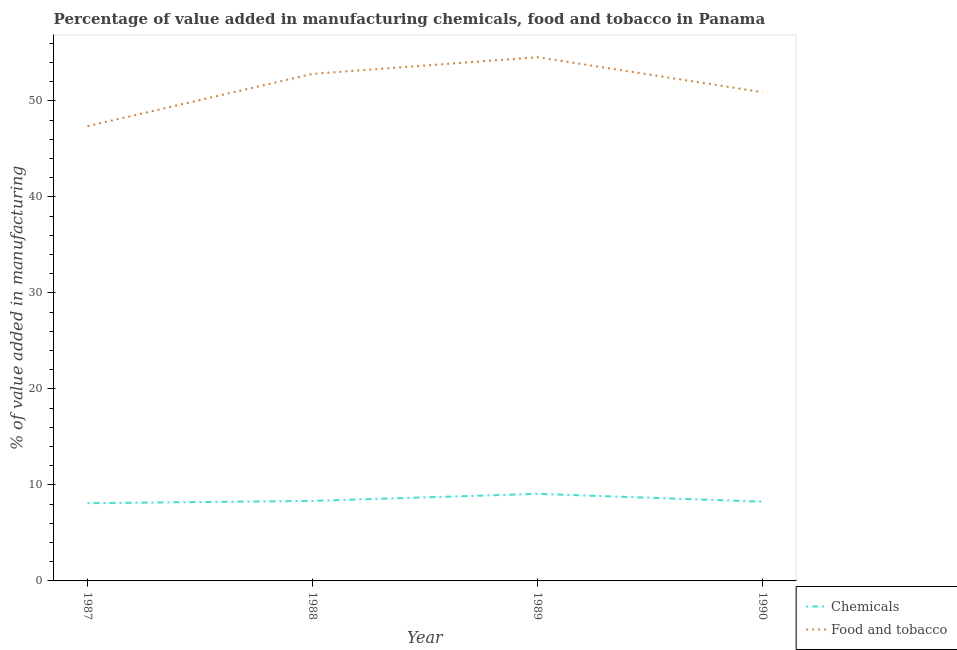Does the line corresponding to value added by manufacturing food and tobacco intersect with the line corresponding to value added by  manufacturing chemicals?
Ensure brevity in your answer.  No. What is the value added by manufacturing food and tobacco in 1989?
Provide a succinct answer. 54.56. Across all years, what is the maximum value added by  manufacturing chemicals?
Your answer should be compact. 9.07. Across all years, what is the minimum value added by  manufacturing chemicals?
Offer a very short reply. 8.1. What is the total value added by  manufacturing chemicals in the graph?
Your response must be concise. 33.76. What is the difference between the value added by  manufacturing chemicals in 1989 and that in 1990?
Ensure brevity in your answer.  0.81. What is the difference between the value added by  manufacturing chemicals in 1989 and the value added by manufacturing food and tobacco in 1990?
Keep it short and to the point. -41.85. What is the average value added by  manufacturing chemicals per year?
Your response must be concise. 8.44. In the year 1988, what is the difference between the value added by manufacturing food and tobacco and value added by  manufacturing chemicals?
Make the answer very short. 44.49. In how many years, is the value added by manufacturing food and tobacco greater than 36 %?
Offer a terse response. 4. What is the ratio of the value added by manufacturing food and tobacco in 1989 to that in 1990?
Offer a very short reply. 1.07. Is the value added by manufacturing food and tobacco in 1987 less than that in 1988?
Give a very brief answer. Yes. What is the difference between the highest and the second highest value added by manufacturing food and tobacco?
Your answer should be compact. 1.74. What is the difference between the highest and the lowest value added by  manufacturing chemicals?
Keep it short and to the point. 0.97. In how many years, is the value added by manufacturing food and tobacco greater than the average value added by manufacturing food and tobacco taken over all years?
Give a very brief answer. 2. Does the value added by manufacturing food and tobacco monotonically increase over the years?
Offer a very short reply. No. Is the value added by manufacturing food and tobacco strictly greater than the value added by  manufacturing chemicals over the years?
Give a very brief answer. Yes. How many lines are there?
Your answer should be very brief. 2. Does the graph contain any zero values?
Give a very brief answer. No. Does the graph contain grids?
Your answer should be very brief. No. How many legend labels are there?
Give a very brief answer. 2. How are the legend labels stacked?
Provide a short and direct response. Vertical. What is the title of the graph?
Offer a terse response. Percentage of value added in manufacturing chemicals, food and tobacco in Panama. What is the label or title of the Y-axis?
Your response must be concise. % of value added in manufacturing. What is the % of value added in manufacturing of Chemicals in 1987?
Your response must be concise. 8.1. What is the % of value added in manufacturing of Food and tobacco in 1987?
Your answer should be compact. 47.37. What is the % of value added in manufacturing of Chemicals in 1988?
Provide a succinct answer. 8.34. What is the % of value added in manufacturing of Food and tobacco in 1988?
Provide a short and direct response. 52.82. What is the % of value added in manufacturing in Chemicals in 1989?
Ensure brevity in your answer.  9.07. What is the % of value added in manufacturing in Food and tobacco in 1989?
Your answer should be very brief. 54.56. What is the % of value added in manufacturing of Chemicals in 1990?
Ensure brevity in your answer.  8.26. What is the % of value added in manufacturing in Food and tobacco in 1990?
Your answer should be very brief. 50.92. Across all years, what is the maximum % of value added in manufacturing in Chemicals?
Make the answer very short. 9.07. Across all years, what is the maximum % of value added in manufacturing of Food and tobacco?
Offer a very short reply. 54.56. Across all years, what is the minimum % of value added in manufacturing in Chemicals?
Offer a terse response. 8.1. Across all years, what is the minimum % of value added in manufacturing of Food and tobacco?
Offer a terse response. 47.37. What is the total % of value added in manufacturing in Chemicals in the graph?
Your response must be concise. 33.76. What is the total % of value added in manufacturing in Food and tobacco in the graph?
Your response must be concise. 205.68. What is the difference between the % of value added in manufacturing of Chemicals in 1987 and that in 1988?
Provide a succinct answer. -0.24. What is the difference between the % of value added in manufacturing in Food and tobacco in 1987 and that in 1988?
Offer a very short reply. -5.45. What is the difference between the % of value added in manufacturing of Chemicals in 1987 and that in 1989?
Your answer should be very brief. -0.97. What is the difference between the % of value added in manufacturing in Food and tobacco in 1987 and that in 1989?
Your response must be concise. -7.19. What is the difference between the % of value added in manufacturing of Chemicals in 1987 and that in 1990?
Provide a short and direct response. -0.16. What is the difference between the % of value added in manufacturing of Food and tobacco in 1987 and that in 1990?
Offer a terse response. -3.54. What is the difference between the % of value added in manufacturing of Chemicals in 1988 and that in 1989?
Your answer should be very brief. -0.73. What is the difference between the % of value added in manufacturing in Food and tobacco in 1988 and that in 1989?
Your response must be concise. -1.74. What is the difference between the % of value added in manufacturing of Chemicals in 1988 and that in 1990?
Your answer should be very brief. 0.08. What is the difference between the % of value added in manufacturing in Food and tobacco in 1988 and that in 1990?
Offer a very short reply. 1.91. What is the difference between the % of value added in manufacturing of Chemicals in 1989 and that in 1990?
Provide a succinct answer. 0.81. What is the difference between the % of value added in manufacturing in Food and tobacco in 1989 and that in 1990?
Ensure brevity in your answer.  3.65. What is the difference between the % of value added in manufacturing of Chemicals in 1987 and the % of value added in manufacturing of Food and tobacco in 1988?
Give a very brief answer. -44.73. What is the difference between the % of value added in manufacturing of Chemicals in 1987 and the % of value added in manufacturing of Food and tobacco in 1989?
Your response must be concise. -46.47. What is the difference between the % of value added in manufacturing of Chemicals in 1987 and the % of value added in manufacturing of Food and tobacco in 1990?
Give a very brief answer. -42.82. What is the difference between the % of value added in manufacturing of Chemicals in 1988 and the % of value added in manufacturing of Food and tobacco in 1989?
Offer a terse response. -46.23. What is the difference between the % of value added in manufacturing of Chemicals in 1988 and the % of value added in manufacturing of Food and tobacco in 1990?
Offer a very short reply. -42.58. What is the difference between the % of value added in manufacturing in Chemicals in 1989 and the % of value added in manufacturing in Food and tobacco in 1990?
Make the answer very short. -41.85. What is the average % of value added in manufacturing of Chemicals per year?
Provide a succinct answer. 8.44. What is the average % of value added in manufacturing of Food and tobacco per year?
Your answer should be very brief. 51.42. In the year 1987, what is the difference between the % of value added in manufacturing in Chemicals and % of value added in manufacturing in Food and tobacco?
Your response must be concise. -39.28. In the year 1988, what is the difference between the % of value added in manufacturing of Chemicals and % of value added in manufacturing of Food and tobacco?
Give a very brief answer. -44.49. In the year 1989, what is the difference between the % of value added in manufacturing of Chemicals and % of value added in manufacturing of Food and tobacco?
Ensure brevity in your answer.  -45.49. In the year 1990, what is the difference between the % of value added in manufacturing of Chemicals and % of value added in manufacturing of Food and tobacco?
Ensure brevity in your answer.  -42.66. What is the ratio of the % of value added in manufacturing in Chemicals in 1987 to that in 1988?
Provide a short and direct response. 0.97. What is the ratio of the % of value added in manufacturing in Food and tobacco in 1987 to that in 1988?
Ensure brevity in your answer.  0.9. What is the ratio of the % of value added in manufacturing in Chemicals in 1987 to that in 1989?
Your answer should be very brief. 0.89. What is the ratio of the % of value added in manufacturing in Food and tobacco in 1987 to that in 1989?
Your answer should be very brief. 0.87. What is the ratio of the % of value added in manufacturing in Chemicals in 1987 to that in 1990?
Provide a short and direct response. 0.98. What is the ratio of the % of value added in manufacturing of Food and tobacco in 1987 to that in 1990?
Your answer should be very brief. 0.93. What is the ratio of the % of value added in manufacturing in Chemicals in 1988 to that in 1989?
Ensure brevity in your answer.  0.92. What is the ratio of the % of value added in manufacturing of Food and tobacco in 1988 to that in 1989?
Your answer should be compact. 0.97. What is the ratio of the % of value added in manufacturing in Chemicals in 1988 to that in 1990?
Offer a terse response. 1.01. What is the ratio of the % of value added in manufacturing in Food and tobacco in 1988 to that in 1990?
Your answer should be compact. 1.04. What is the ratio of the % of value added in manufacturing of Chemicals in 1989 to that in 1990?
Provide a short and direct response. 1.1. What is the ratio of the % of value added in manufacturing of Food and tobacco in 1989 to that in 1990?
Offer a very short reply. 1.07. What is the difference between the highest and the second highest % of value added in manufacturing of Chemicals?
Offer a very short reply. 0.73. What is the difference between the highest and the second highest % of value added in manufacturing of Food and tobacco?
Your answer should be very brief. 1.74. What is the difference between the highest and the lowest % of value added in manufacturing of Chemicals?
Offer a terse response. 0.97. What is the difference between the highest and the lowest % of value added in manufacturing of Food and tobacco?
Make the answer very short. 7.19. 